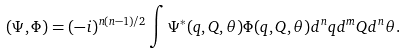<formula> <loc_0><loc_0><loc_500><loc_500>( \Psi , \Phi ) = ( - i ) ^ { n ( n - 1 ) / 2 } \int \Psi ^ { * } ( q , Q , \theta ) \Phi ( q , Q , \theta ) d ^ { n } q d ^ { m } Q d ^ { n } \theta .</formula> 